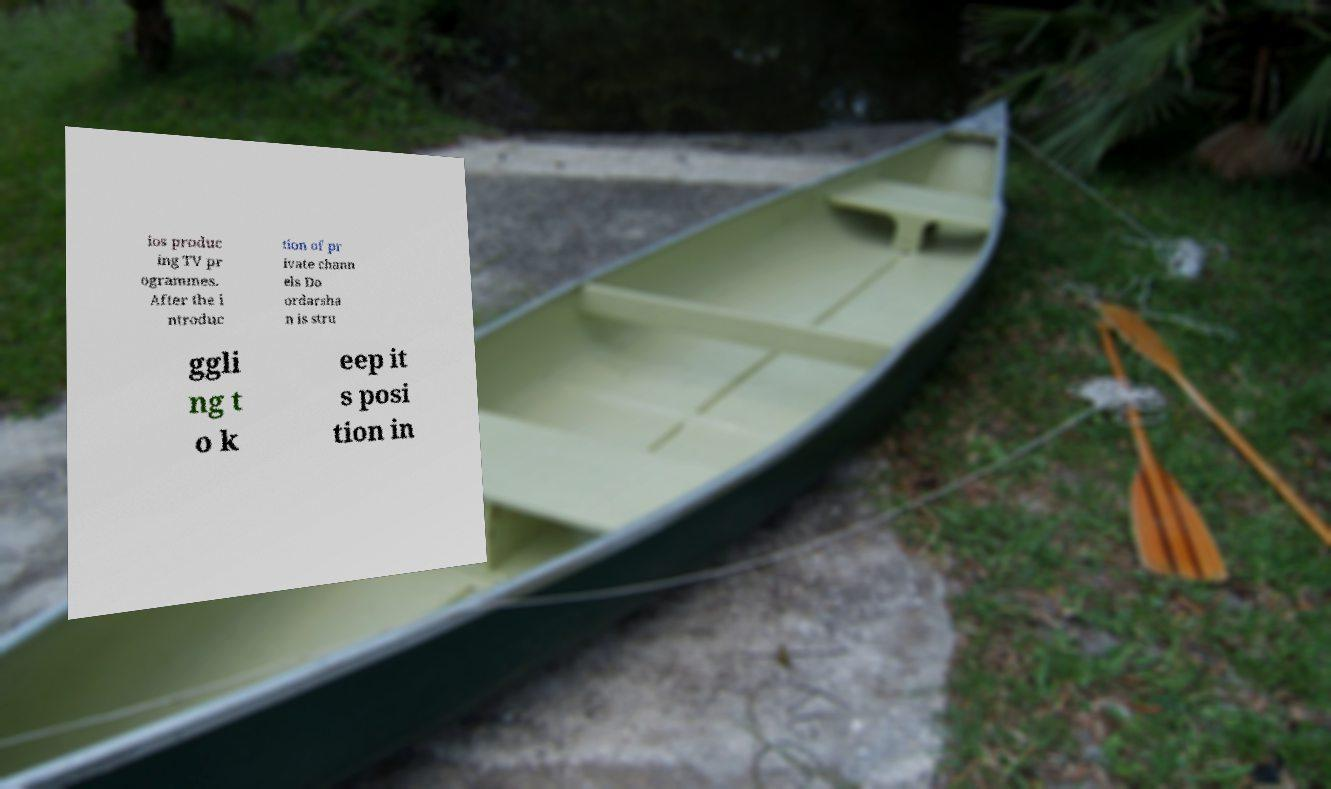I need the written content from this picture converted into text. Can you do that? ios produc ing TV pr ogrammes. After the i ntroduc tion of pr ivate chann els Do ordarsha n is stru ggli ng t o k eep it s posi tion in 